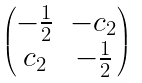Convert formula to latex. <formula><loc_0><loc_0><loc_500><loc_500>\begin{pmatrix} - \frac { 1 } { 2 } & - c _ { 2 } \\ c _ { 2 } & - \frac { 1 } { 2 } \end{pmatrix}</formula> 